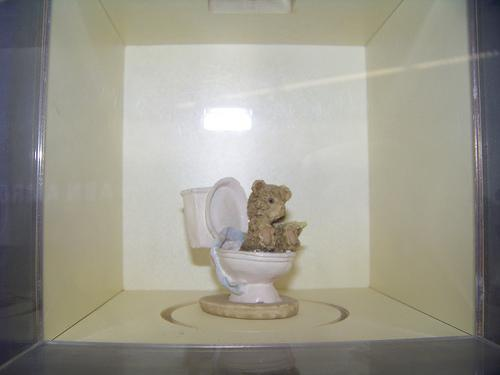What details can you observe about the teddy bear sitting on the toilet in the image? The teddy bear is small and brown with black eyes, and it has little beige leather pads on its underfeet. Describe the setting and the primary objects in the image. The image features a brown teddy bear sitting on a miniature white toilet inside a display case. They are placed on a circular platform with a brown circle on the ground and a white wall behind them. Describe the floor and walls in the image. The floor has a brown circle, and the walls are white with some light mustard yellow areas. Explain the lighting situation in the image, including any reflections. There is a light reflecting on the wall and a rectangular white light reflected on the scene, as well as a reflection of light on plastic and a person's lower body inside the display case. Tell me what color the bear in the image is and where it is placed. The bear in the image is brown and it is sitting on a toilet. List all the colors in the image. Brown, white, blue, gray, black, beige and light mustard yellow. What material is the display case made of and what color are its interior walls? The display case is made of plastic, and the interior walls are white. Mention an accessory seen on the toilet in the image. There is no visible accessory on the toilet in the image. What expression does the teddy bear in the image have? The teddy bear has a vaguely expressionless face. What kind of ground does the toilet rest on in the image? The toilet rests on a small round pancake-like stand. 